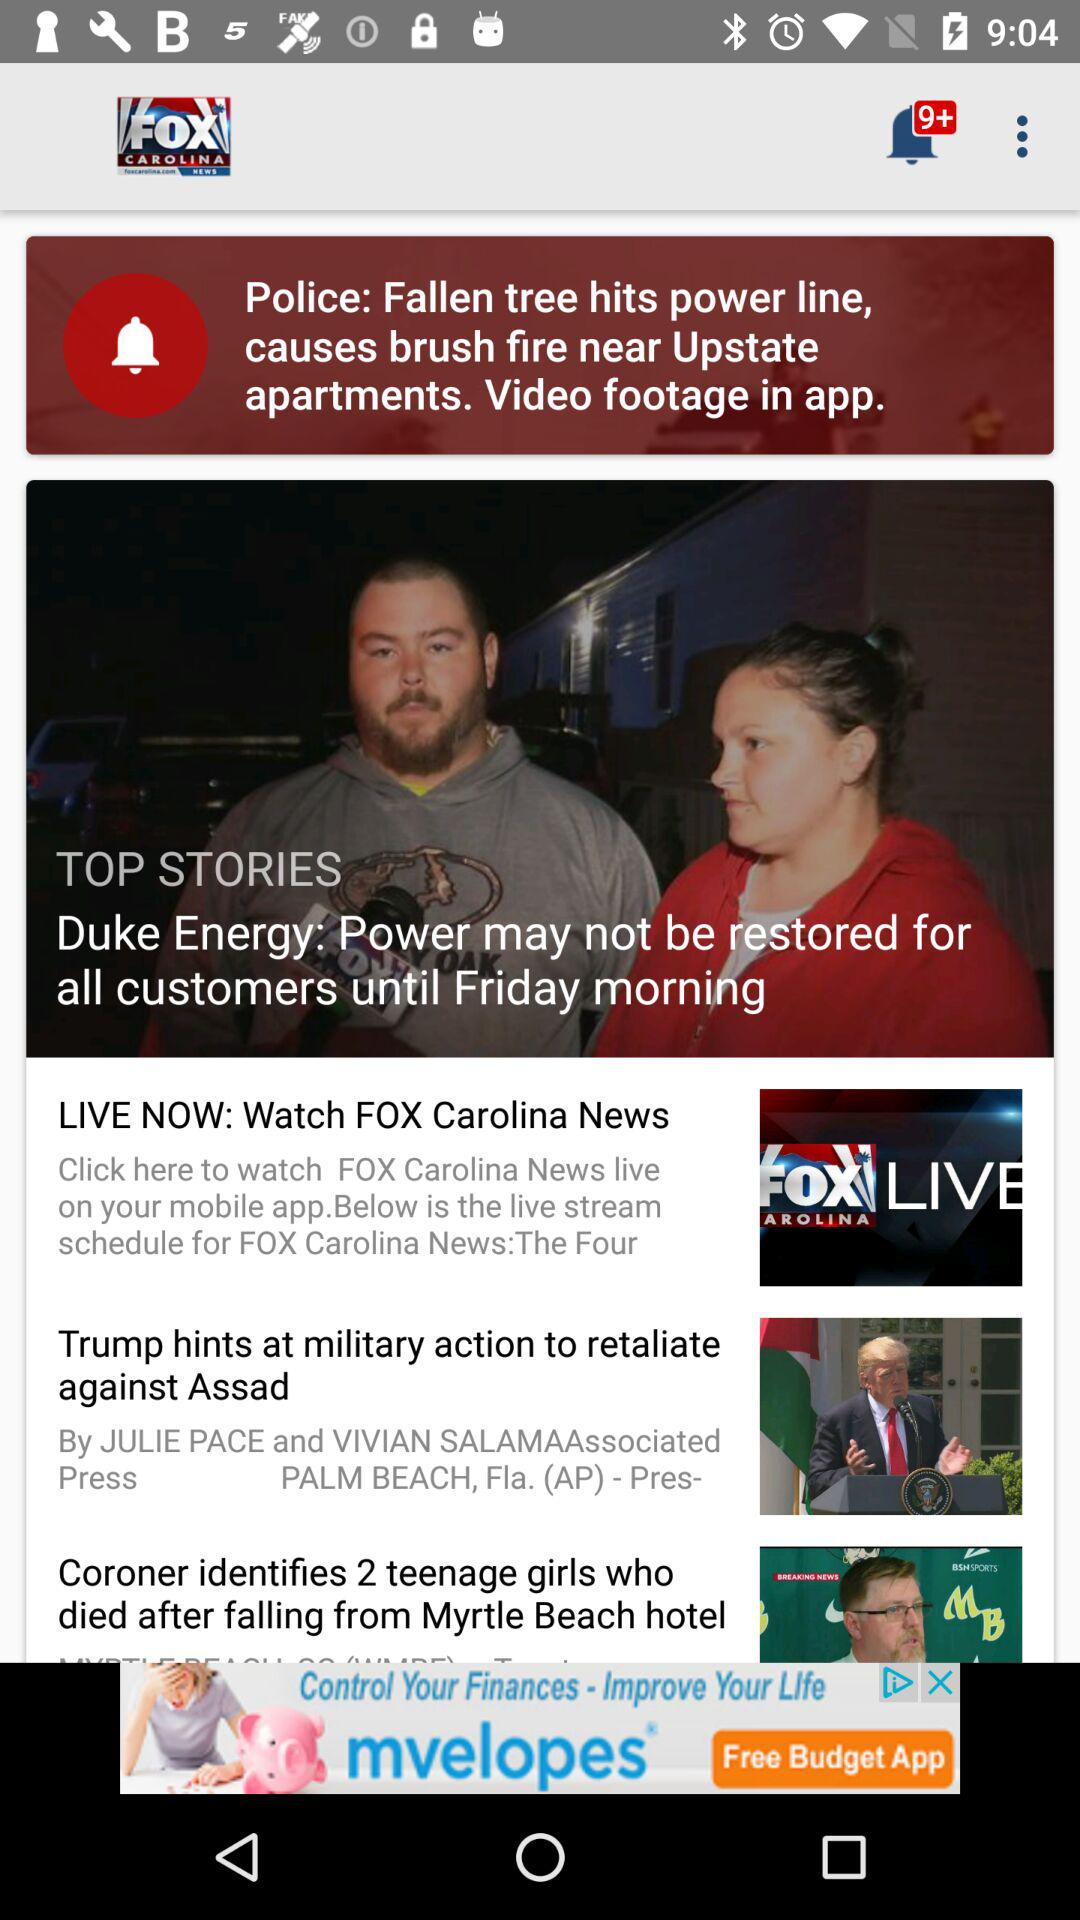How many new notifications are there? There are more than 9 new notifications. 